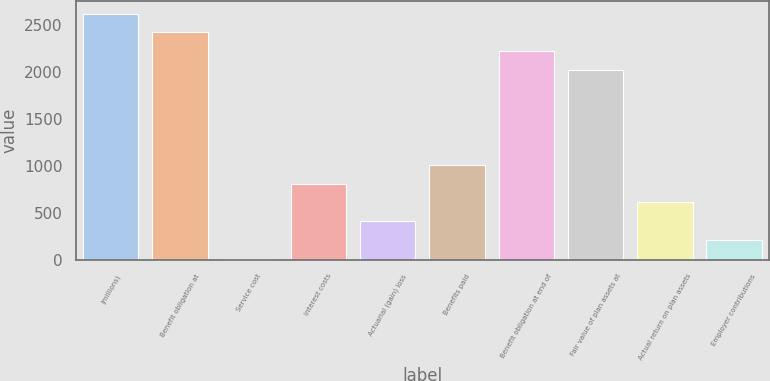<chart> <loc_0><loc_0><loc_500><loc_500><bar_chart><fcel>(millions)<fcel>Benefit obligation at<fcel>Service cost<fcel>Interest costs<fcel>Actuarial (gain) loss<fcel>Benefits paid<fcel>Benefit obligation at end of<fcel>Fair value of plan assets at<fcel>Actual return on plan assets<fcel>Employer contributions<nl><fcel>2617.04<fcel>2416.36<fcel>8.2<fcel>810.92<fcel>409.56<fcel>1011.6<fcel>2215.68<fcel>2015<fcel>610.24<fcel>208.88<nl></chart> 